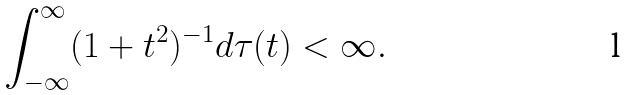<formula> <loc_0><loc_0><loc_500><loc_500>\int _ { - \infty } ^ { \infty } ( 1 + t ^ { 2 } ) ^ { - 1 } d \tau ( t ) < \infty .</formula> 